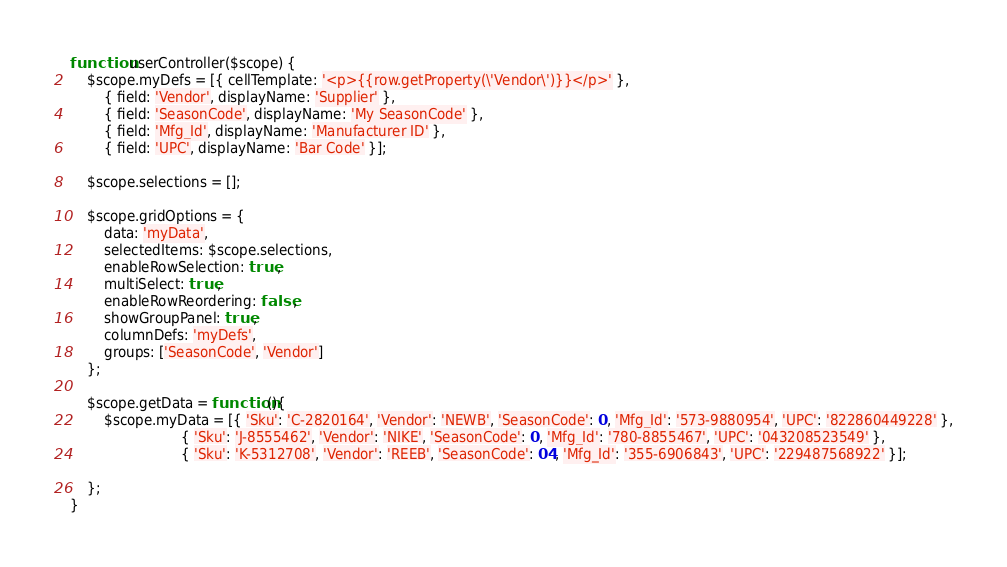<code> <loc_0><loc_0><loc_500><loc_500><_JavaScript_>function userController($scope) {
	$scope.myDefs = [{ cellTemplate: '<p>{{row.getProperty(\'Vendor\')}}</p>' },
        { field: 'Vendor', displayName: 'Supplier' },
        { field: 'SeasonCode', displayName: 'My SeasonCode' },
        { field: 'Mfg_Id', displayName: 'Manufacturer ID' },
        { field: 'UPC', displayName: 'Bar Code' }];
		
	$scope.selections = [];
	
	$scope.gridOptions = {
        data: 'myData',
        selectedItems: $scope.selections,
		enableRowSelection: true,
		multiSelect: true,
        enableRowReordering: false,
        showGroupPanel: true,
        columnDefs: 'myDefs',
		groups: ['SeasonCode', 'Vendor']
    };
	
	$scope.getData = function(){
		$scope.myData = [{ 'Sku': 'C-2820164', 'Vendor': 'NEWB', 'SeasonCode': 0, 'Mfg_Id': '573-9880954', 'UPC': '822860449228' },
						  { 'Sku': 'J-8555462', 'Vendor': 'NIKE', 'SeasonCode': 0, 'Mfg_Id': '780-8855467', 'UPC': '043208523549' },
						  { 'Sku': 'K-5312708', 'Vendor': 'REEB', 'SeasonCode': 04, 'Mfg_Id': '355-6906843', 'UPC': '229487568922' }];
					  
	};
}</code> 